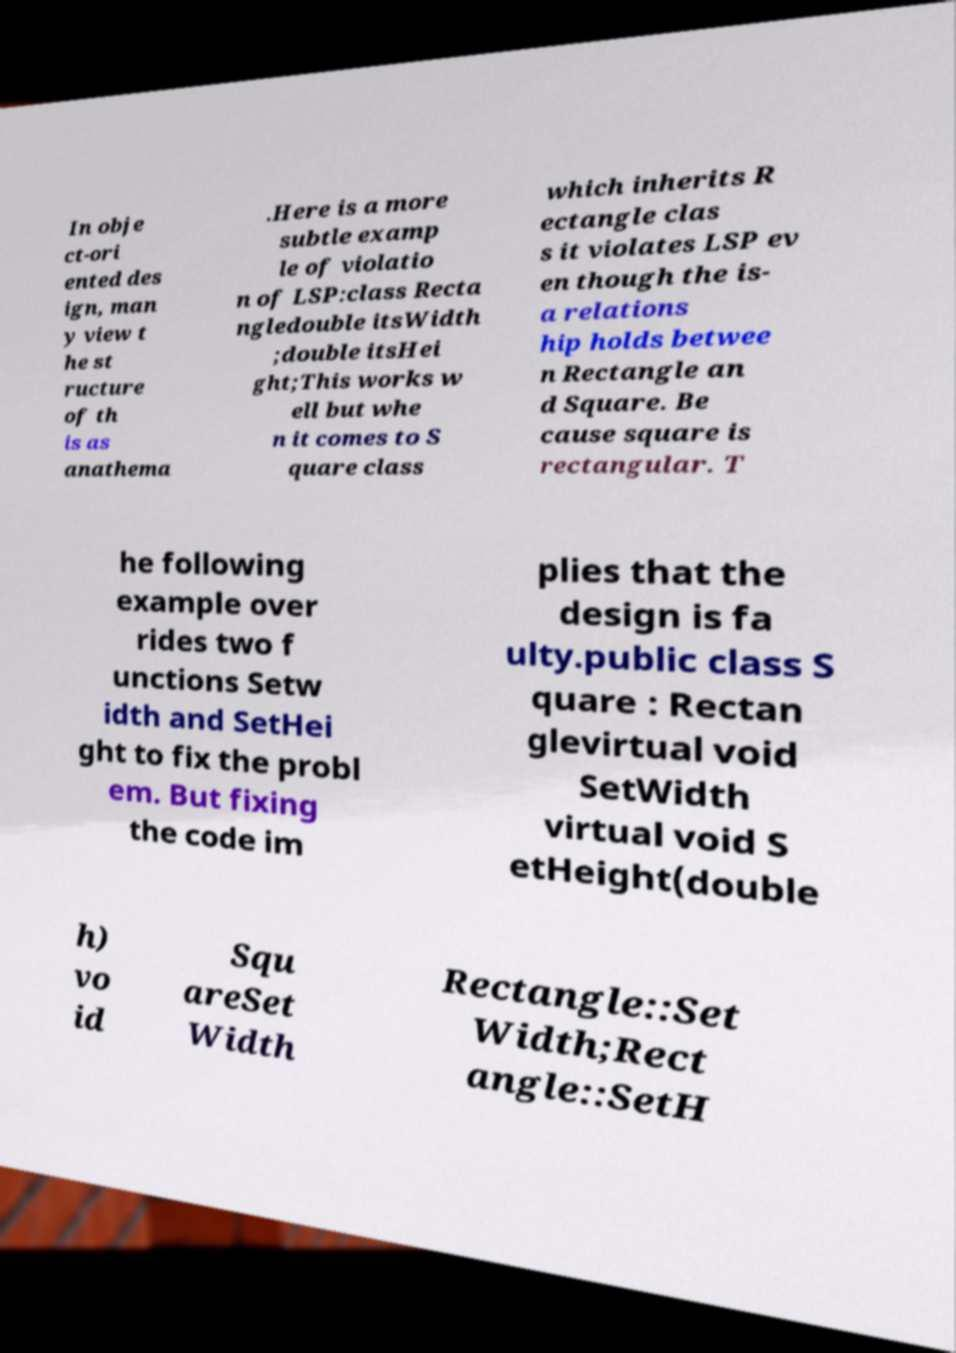Please identify and transcribe the text found in this image. In obje ct-ori ented des ign, man y view t he st ructure of th is as anathema .Here is a more subtle examp le of violatio n of LSP:class Recta ngledouble itsWidth ;double itsHei ght;This works w ell but whe n it comes to S quare class which inherits R ectangle clas s it violates LSP ev en though the is- a relations hip holds betwee n Rectangle an d Square. Be cause square is rectangular. T he following example over rides two f unctions Setw idth and SetHei ght to fix the probl em. But fixing the code im plies that the design is fa ulty.public class S quare : Rectan glevirtual void SetWidth virtual void S etHeight(double h) vo id Squ areSet Width Rectangle::Set Width;Rect angle::SetH 